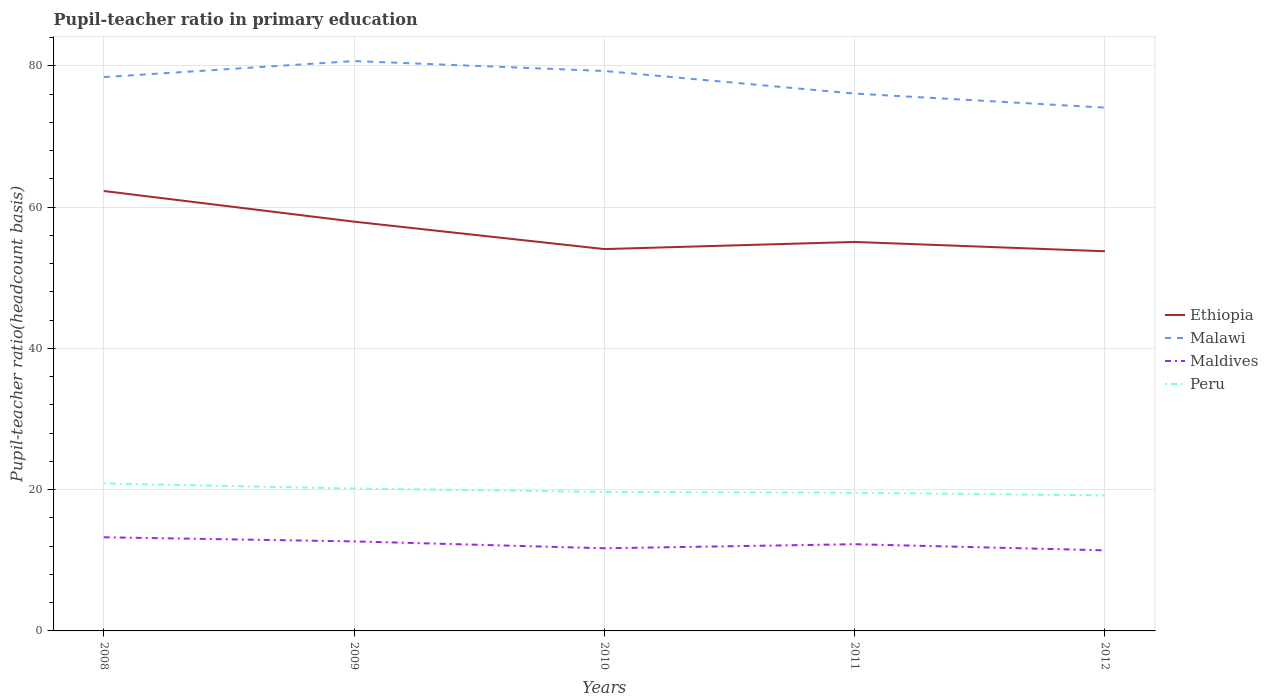Does the line corresponding to Maldives intersect with the line corresponding to Peru?
Offer a terse response. No. Is the number of lines equal to the number of legend labels?
Keep it short and to the point. Yes. Across all years, what is the maximum pupil-teacher ratio in primary education in Maldives?
Keep it short and to the point. 11.41. In which year was the pupil-teacher ratio in primary education in Malawi maximum?
Your answer should be compact. 2012. What is the total pupil-teacher ratio in primary education in Malawi in the graph?
Ensure brevity in your answer.  4.32. What is the difference between the highest and the second highest pupil-teacher ratio in primary education in Maldives?
Your answer should be compact. 1.85. What is the difference between the highest and the lowest pupil-teacher ratio in primary education in Ethiopia?
Provide a short and direct response. 2. How many lines are there?
Your answer should be very brief. 4. How many years are there in the graph?
Your answer should be very brief. 5. What is the difference between two consecutive major ticks on the Y-axis?
Give a very brief answer. 20. Are the values on the major ticks of Y-axis written in scientific E-notation?
Your response must be concise. No. Does the graph contain any zero values?
Provide a succinct answer. No. Does the graph contain grids?
Make the answer very short. Yes. Where does the legend appear in the graph?
Offer a terse response. Center right. How are the legend labels stacked?
Your answer should be very brief. Vertical. What is the title of the graph?
Your response must be concise. Pupil-teacher ratio in primary education. What is the label or title of the X-axis?
Give a very brief answer. Years. What is the label or title of the Y-axis?
Ensure brevity in your answer.  Pupil-teacher ratio(headcount basis). What is the Pupil-teacher ratio(headcount basis) in Ethiopia in 2008?
Your answer should be compact. 62.28. What is the Pupil-teacher ratio(headcount basis) in Malawi in 2008?
Your answer should be compact. 78.41. What is the Pupil-teacher ratio(headcount basis) of Maldives in 2008?
Give a very brief answer. 13.26. What is the Pupil-teacher ratio(headcount basis) in Peru in 2008?
Keep it short and to the point. 20.88. What is the Pupil-teacher ratio(headcount basis) of Ethiopia in 2009?
Your response must be concise. 57.94. What is the Pupil-teacher ratio(headcount basis) of Malawi in 2009?
Provide a succinct answer. 80.68. What is the Pupil-teacher ratio(headcount basis) in Maldives in 2009?
Offer a terse response. 12.68. What is the Pupil-teacher ratio(headcount basis) of Peru in 2009?
Give a very brief answer. 20.16. What is the Pupil-teacher ratio(headcount basis) in Ethiopia in 2010?
Give a very brief answer. 54.06. What is the Pupil-teacher ratio(headcount basis) of Malawi in 2010?
Provide a short and direct response. 79.27. What is the Pupil-teacher ratio(headcount basis) in Maldives in 2010?
Provide a short and direct response. 11.7. What is the Pupil-teacher ratio(headcount basis) of Peru in 2010?
Keep it short and to the point. 19.68. What is the Pupil-teacher ratio(headcount basis) in Ethiopia in 2011?
Give a very brief answer. 55.07. What is the Pupil-teacher ratio(headcount basis) of Malawi in 2011?
Ensure brevity in your answer.  76.07. What is the Pupil-teacher ratio(headcount basis) in Maldives in 2011?
Ensure brevity in your answer.  12.28. What is the Pupil-teacher ratio(headcount basis) in Peru in 2011?
Give a very brief answer. 19.56. What is the Pupil-teacher ratio(headcount basis) of Ethiopia in 2012?
Your response must be concise. 53.75. What is the Pupil-teacher ratio(headcount basis) of Malawi in 2012?
Keep it short and to the point. 74.09. What is the Pupil-teacher ratio(headcount basis) in Maldives in 2012?
Keep it short and to the point. 11.41. What is the Pupil-teacher ratio(headcount basis) in Peru in 2012?
Keep it short and to the point. 19.19. Across all years, what is the maximum Pupil-teacher ratio(headcount basis) of Ethiopia?
Your answer should be very brief. 62.28. Across all years, what is the maximum Pupil-teacher ratio(headcount basis) in Malawi?
Ensure brevity in your answer.  80.68. Across all years, what is the maximum Pupil-teacher ratio(headcount basis) of Maldives?
Offer a very short reply. 13.26. Across all years, what is the maximum Pupil-teacher ratio(headcount basis) in Peru?
Your answer should be very brief. 20.88. Across all years, what is the minimum Pupil-teacher ratio(headcount basis) of Ethiopia?
Keep it short and to the point. 53.75. Across all years, what is the minimum Pupil-teacher ratio(headcount basis) in Malawi?
Offer a terse response. 74.09. Across all years, what is the minimum Pupil-teacher ratio(headcount basis) in Maldives?
Provide a succinct answer. 11.41. Across all years, what is the minimum Pupil-teacher ratio(headcount basis) of Peru?
Provide a short and direct response. 19.19. What is the total Pupil-teacher ratio(headcount basis) of Ethiopia in the graph?
Keep it short and to the point. 283.1. What is the total Pupil-teacher ratio(headcount basis) in Malawi in the graph?
Your answer should be compact. 388.52. What is the total Pupil-teacher ratio(headcount basis) of Maldives in the graph?
Your answer should be very brief. 61.32. What is the total Pupil-teacher ratio(headcount basis) of Peru in the graph?
Provide a succinct answer. 99.47. What is the difference between the Pupil-teacher ratio(headcount basis) in Ethiopia in 2008 and that in 2009?
Give a very brief answer. 4.34. What is the difference between the Pupil-teacher ratio(headcount basis) of Malawi in 2008 and that in 2009?
Provide a short and direct response. -2.27. What is the difference between the Pupil-teacher ratio(headcount basis) in Maldives in 2008 and that in 2009?
Make the answer very short. 0.58. What is the difference between the Pupil-teacher ratio(headcount basis) in Peru in 2008 and that in 2009?
Provide a succinct answer. 0.72. What is the difference between the Pupil-teacher ratio(headcount basis) of Ethiopia in 2008 and that in 2010?
Provide a succinct answer. 8.22. What is the difference between the Pupil-teacher ratio(headcount basis) in Malawi in 2008 and that in 2010?
Provide a short and direct response. -0.87. What is the difference between the Pupil-teacher ratio(headcount basis) of Maldives in 2008 and that in 2010?
Your response must be concise. 1.56. What is the difference between the Pupil-teacher ratio(headcount basis) in Peru in 2008 and that in 2010?
Give a very brief answer. 1.2. What is the difference between the Pupil-teacher ratio(headcount basis) of Ethiopia in 2008 and that in 2011?
Make the answer very short. 7.21. What is the difference between the Pupil-teacher ratio(headcount basis) in Malawi in 2008 and that in 2011?
Keep it short and to the point. 2.33. What is the difference between the Pupil-teacher ratio(headcount basis) of Maldives in 2008 and that in 2011?
Make the answer very short. 0.98. What is the difference between the Pupil-teacher ratio(headcount basis) in Peru in 2008 and that in 2011?
Provide a short and direct response. 1.31. What is the difference between the Pupil-teacher ratio(headcount basis) of Ethiopia in 2008 and that in 2012?
Provide a short and direct response. 8.53. What is the difference between the Pupil-teacher ratio(headcount basis) in Malawi in 2008 and that in 2012?
Provide a succinct answer. 4.32. What is the difference between the Pupil-teacher ratio(headcount basis) in Maldives in 2008 and that in 2012?
Keep it short and to the point. 1.85. What is the difference between the Pupil-teacher ratio(headcount basis) in Peru in 2008 and that in 2012?
Your answer should be very brief. 1.69. What is the difference between the Pupil-teacher ratio(headcount basis) of Ethiopia in 2009 and that in 2010?
Make the answer very short. 3.88. What is the difference between the Pupil-teacher ratio(headcount basis) in Malawi in 2009 and that in 2010?
Keep it short and to the point. 1.41. What is the difference between the Pupil-teacher ratio(headcount basis) of Maldives in 2009 and that in 2010?
Provide a short and direct response. 0.98. What is the difference between the Pupil-teacher ratio(headcount basis) in Peru in 2009 and that in 2010?
Your answer should be very brief. 0.48. What is the difference between the Pupil-teacher ratio(headcount basis) of Ethiopia in 2009 and that in 2011?
Provide a succinct answer. 2.87. What is the difference between the Pupil-teacher ratio(headcount basis) in Malawi in 2009 and that in 2011?
Keep it short and to the point. 4.61. What is the difference between the Pupil-teacher ratio(headcount basis) of Maldives in 2009 and that in 2011?
Keep it short and to the point. 0.4. What is the difference between the Pupil-teacher ratio(headcount basis) of Peru in 2009 and that in 2011?
Provide a succinct answer. 0.59. What is the difference between the Pupil-teacher ratio(headcount basis) in Ethiopia in 2009 and that in 2012?
Provide a succinct answer. 4.19. What is the difference between the Pupil-teacher ratio(headcount basis) of Malawi in 2009 and that in 2012?
Your response must be concise. 6.59. What is the difference between the Pupil-teacher ratio(headcount basis) in Maldives in 2009 and that in 2012?
Your answer should be compact. 1.27. What is the difference between the Pupil-teacher ratio(headcount basis) of Peru in 2009 and that in 2012?
Your answer should be compact. 0.97. What is the difference between the Pupil-teacher ratio(headcount basis) in Ethiopia in 2010 and that in 2011?
Your answer should be very brief. -1.01. What is the difference between the Pupil-teacher ratio(headcount basis) in Malawi in 2010 and that in 2011?
Ensure brevity in your answer.  3.2. What is the difference between the Pupil-teacher ratio(headcount basis) of Maldives in 2010 and that in 2011?
Your answer should be very brief. -0.57. What is the difference between the Pupil-teacher ratio(headcount basis) of Peru in 2010 and that in 2011?
Make the answer very short. 0.12. What is the difference between the Pupil-teacher ratio(headcount basis) of Ethiopia in 2010 and that in 2012?
Give a very brief answer. 0.31. What is the difference between the Pupil-teacher ratio(headcount basis) of Malawi in 2010 and that in 2012?
Make the answer very short. 5.19. What is the difference between the Pupil-teacher ratio(headcount basis) of Maldives in 2010 and that in 2012?
Your answer should be very brief. 0.29. What is the difference between the Pupil-teacher ratio(headcount basis) in Peru in 2010 and that in 2012?
Your answer should be very brief. 0.49. What is the difference between the Pupil-teacher ratio(headcount basis) in Ethiopia in 2011 and that in 2012?
Make the answer very short. 1.32. What is the difference between the Pupil-teacher ratio(headcount basis) in Malawi in 2011 and that in 2012?
Give a very brief answer. 1.99. What is the difference between the Pupil-teacher ratio(headcount basis) of Maldives in 2011 and that in 2012?
Your answer should be compact. 0.87. What is the difference between the Pupil-teacher ratio(headcount basis) in Peru in 2011 and that in 2012?
Your answer should be compact. 0.38. What is the difference between the Pupil-teacher ratio(headcount basis) in Ethiopia in 2008 and the Pupil-teacher ratio(headcount basis) in Malawi in 2009?
Ensure brevity in your answer.  -18.4. What is the difference between the Pupil-teacher ratio(headcount basis) in Ethiopia in 2008 and the Pupil-teacher ratio(headcount basis) in Maldives in 2009?
Your answer should be compact. 49.61. What is the difference between the Pupil-teacher ratio(headcount basis) of Ethiopia in 2008 and the Pupil-teacher ratio(headcount basis) of Peru in 2009?
Your response must be concise. 42.13. What is the difference between the Pupil-teacher ratio(headcount basis) in Malawi in 2008 and the Pupil-teacher ratio(headcount basis) in Maldives in 2009?
Keep it short and to the point. 65.73. What is the difference between the Pupil-teacher ratio(headcount basis) of Malawi in 2008 and the Pupil-teacher ratio(headcount basis) of Peru in 2009?
Provide a short and direct response. 58.25. What is the difference between the Pupil-teacher ratio(headcount basis) of Maldives in 2008 and the Pupil-teacher ratio(headcount basis) of Peru in 2009?
Ensure brevity in your answer.  -6.9. What is the difference between the Pupil-teacher ratio(headcount basis) in Ethiopia in 2008 and the Pupil-teacher ratio(headcount basis) in Malawi in 2010?
Offer a very short reply. -16.99. What is the difference between the Pupil-teacher ratio(headcount basis) of Ethiopia in 2008 and the Pupil-teacher ratio(headcount basis) of Maldives in 2010?
Your answer should be very brief. 50.58. What is the difference between the Pupil-teacher ratio(headcount basis) of Ethiopia in 2008 and the Pupil-teacher ratio(headcount basis) of Peru in 2010?
Your answer should be very brief. 42.6. What is the difference between the Pupil-teacher ratio(headcount basis) of Malawi in 2008 and the Pupil-teacher ratio(headcount basis) of Maldives in 2010?
Your response must be concise. 66.7. What is the difference between the Pupil-teacher ratio(headcount basis) of Malawi in 2008 and the Pupil-teacher ratio(headcount basis) of Peru in 2010?
Your answer should be very brief. 58.72. What is the difference between the Pupil-teacher ratio(headcount basis) of Maldives in 2008 and the Pupil-teacher ratio(headcount basis) of Peru in 2010?
Provide a succinct answer. -6.42. What is the difference between the Pupil-teacher ratio(headcount basis) of Ethiopia in 2008 and the Pupil-teacher ratio(headcount basis) of Malawi in 2011?
Keep it short and to the point. -13.79. What is the difference between the Pupil-teacher ratio(headcount basis) in Ethiopia in 2008 and the Pupil-teacher ratio(headcount basis) in Maldives in 2011?
Your answer should be compact. 50.01. What is the difference between the Pupil-teacher ratio(headcount basis) in Ethiopia in 2008 and the Pupil-teacher ratio(headcount basis) in Peru in 2011?
Give a very brief answer. 42.72. What is the difference between the Pupil-teacher ratio(headcount basis) in Malawi in 2008 and the Pupil-teacher ratio(headcount basis) in Maldives in 2011?
Your response must be concise. 66.13. What is the difference between the Pupil-teacher ratio(headcount basis) of Malawi in 2008 and the Pupil-teacher ratio(headcount basis) of Peru in 2011?
Offer a terse response. 58.84. What is the difference between the Pupil-teacher ratio(headcount basis) in Maldives in 2008 and the Pupil-teacher ratio(headcount basis) in Peru in 2011?
Provide a succinct answer. -6.3. What is the difference between the Pupil-teacher ratio(headcount basis) in Ethiopia in 2008 and the Pupil-teacher ratio(headcount basis) in Malawi in 2012?
Offer a terse response. -11.8. What is the difference between the Pupil-teacher ratio(headcount basis) of Ethiopia in 2008 and the Pupil-teacher ratio(headcount basis) of Maldives in 2012?
Keep it short and to the point. 50.87. What is the difference between the Pupil-teacher ratio(headcount basis) in Ethiopia in 2008 and the Pupil-teacher ratio(headcount basis) in Peru in 2012?
Offer a terse response. 43.09. What is the difference between the Pupil-teacher ratio(headcount basis) of Malawi in 2008 and the Pupil-teacher ratio(headcount basis) of Maldives in 2012?
Offer a very short reply. 67. What is the difference between the Pupil-teacher ratio(headcount basis) of Malawi in 2008 and the Pupil-teacher ratio(headcount basis) of Peru in 2012?
Give a very brief answer. 59.22. What is the difference between the Pupil-teacher ratio(headcount basis) of Maldives in 2008 and the Pupil-teacher ratio(headcount basis) of Peru in 2012?
Offer a very short reply. -5.93. What is the difference between the Pupil-teacher ratio(headcount basis) in Ethiopia in 2009 and the Pupil-teacher ratio(headcount basis) in Malawi in 2010?
Ensure brevity in your answer.  -21.33. What is the difference between the Pupil-teacher ratio(headcount basis) in Ethiopia in 2009 and the Pupil-teacher ratio(headcount basis) in Maldives in 2010?
Make the answer very short. 46.24. What is the difference between the Pupil-teacher ratio(headcount basis) in Ethiopia in 2009 and the Pupil-teacher ratio(headcount basis) in Peru in 2010?
Offer a terse response. 38.26. What is the difference between the Pupil-teacher ratio(headcount basis) of Malawi in 2009 and the Pupil-teacher ratio(headcount basis) of Maldives in 2010?
Give a very brief answer. 68.98. What is the difference between the Pupil-teacher ratio(headcount basis) in Malawi in 2009 and the Pupil-teacher ratio(headcount basis) in Peru in 2010?
Your response must be concise. 61. What is the difference between the Pupil-teacher ratio(headcount basis) in Maldives in 2009 and the Pupil-teacher ratio(headcount basis) in Peru in 2010?
Your answer should be very brief. -7. What is the difference between the Pupil-teacher ratio(headcount basis) in Ethiopia in 2009 and the Pupil-teacher ratio(headcount basis) in Malawi in 2011?
Your answer should be compact. -18.13. What is the difference between the Pupil-teacher ratio(headcount basis) in Ethiopia in 2009 and the Pupil-teacher ratio(headcount basis) in Maldives in 2011?
Your answer should be compact. 45.67. What is the difference between the Pupil-teacher ratio(headcount basis) in Ethiopia in 2009 and the Pupil-teacher ratio(headcount basis) in Peru in 2011?
Keep it short and to the point. 38.38. What is the difference between the Pupil-teacher ratio(headcount basis) in Malawi in 2009 and the Pupil-teacher ratio(headcount basis) in Maldives in 2011?
Provide a succinct answer. 68.4. What is the difference between the Pupil-teacher ratio(headcount basis) in Malawi in 2009 and the Pupil-teacher ratio(headcount basis) in Peru in 2011?
Offer a very short reply. 61.12. What is the difference between the Pupil-teacher ratio(headcount basis) in Maldives in 2009 and the Pupil-teacher ratio(headcount basis) in Peru in 2011?
Make the answer very short. -6.89. What is the difference between the Pupil-teacher ratio(headcount basis) of Ethiopia in 2009 and the Pupil-teacher ratio(headcount basis) of Malawi in 2012?
Ensure brevity in your answer.  -16.15. What is the difference between the Pupil-teacher ratio(headcount basis) in Ethiopia in 2009 and the Pupil-teacher ratio(headcount basis) in Maldives in 2012?
Provide a short and direct response. 46.53. What is the difference between the Pupil-teacher ratio(headcount basis) of Ethiopia in 2009 and the Pupil-teacher ratio(headcount basis) of Peru in 2012?
Offer a terse response. 38.75. What is the difference between the Pupil-teacher ratio(headcount basis) of Malawi in 2009 and the Pupil-teacher ratio(headcount basis) of Maldives in 2012?
Provide a succinct answer. 69.27. What is the difference between the Pupil-teacher ratio(headcount basis) in Malawi in 2009 and the Pupil-teacher ratio(headcount basis) in Peru in 2012?
Give a very brief answer. 61.49. What is the difference between the Pupil-teacher ratio(headcount basis) of Maldives in 2009 and the Pupil-teacher ratio(headcount basis) of Peru in 2012?
Your answer should be very brief. -6.51. What is the difference between the Pupil-teacher ratio(headcount basis) in Ethiopia in 2010 and the Pupil-teacher ratio(headcount basis) in Malawi in 2011?
Offer a very short reply. -22.02. What is the difference between the Pupil-teacher ratio(headcount basis) in Ethiopia in 2010 and the Pupil-teacher ratio(headcount basis) in Maldives in 2011?
Your answer should be compact. 41.78. What is the difference between the Pupil-teacher ratio(headcount basis) of Ethiopia in 2010 and the Pupil-teacher ratio(headcount basis) of Peru in 2011?
Give a very brief answer. 34.49. What is the difference between the Pupil-teacher ratio(headcount basis) in Malawi in 2010 and the Pupil-teacher ratio(headcount basis) in Maldives in 2011?
Provide a short and direct response. 67. What is the difference between the Pupil-teacher ratio(headcount basis) in Malawi in 2010 and the Pupil-teacher ratio(headcount basis) in Peru in 2011?
Provide a succinct answer. 59.71. What is the difference between the Pupil-teacher ratio(headcount basis) of Maldives in 2010 and the Pupil-teacher ratio(headcount basis) of Peru in 2011?
Provide a succinct answer. -7.86. What is the difference between the Pupil-teacher ratio(headcount basis) in Ethiopia in 2010 and the Pupil-teacher ratio(headcount basis) in Malawi in 2012?
Give a very brief answer. -20.03. What is the difference between the Pupil-teacher ratio(headcount basis) in Ethiopia in 2010 and the Pupil-teacher ratio(headcount basis) in Maldives in 2012?
Ensure brevity in your answer.  42.65. What is the difference between the Pupil-teacher ratio(headcount basis) in Ethiopia in 2010 and the Pupil-teacher ratio(headcount basis) in Peru in 2012?
Offer a very short reply. 34.87. What is the difference between the Pupil-teacher ratio(headcount basis) of Malawi in 2010 and the Pupil-teacher ratio(headcount basis) of Maldives in 2012?
Offer a terse response. 67.86. What is the difference between the Pupil-teacher ratio(headcount basis) in Malawi in 2010 and the Pupil-teacher ratio(headcount basis) in Peru in 2012?
Offer a terse response. 60.08. What is the difference between the Pupil-teacher ratio(headcount basis) in Maldives in 2010 and the Pupil-teacher ratio(headcount basis) in Peru in 2012?
Give a very brief answer. -7.49. What is the difference between the Pupil-teacher ratio(headcount basis) of Ethiopia in 2011 and the Pupil-teacher ratio(headcount basis) of Malawi in 2012?
Provide a succinct answer. -19.02. What is the difference between the Pupil-teacher ratio(headcount basis) of Ethiopia in 2011 and the Pupil-teacher ratio(headcount basis) of Maldives in 2012?
Make the answer very short. 43.66. What is the difference between the Pupil-teacher ratio(headcount basis) of Ethiopia in 2011 and the Pupil-teacher ratio(headcount basis) of Peru in 2012?
Give a very brief answer. 35.88. What is the difference between the Pupil-teacher ratio(headcount basis) of Malawi in 2011 and the Pupil-teacher ratio(headcount basis) of Maldives in 2012?
Your answer should be very brief. 64.66. What is the difference between the Pupil-teacher ratio(headcount basis) in Malawi in 2011 and the Pupil-teacher ratio(headcount basis) in Peru in 2012?
Ensure brevity in your answer.  56.89. What is the difference between the Pupil-teacher ratio(headcount basis) of Maldives in 2011 and the Pupil-teacher ratio(headcount basis) of Peru in 2012?
Provide a short and direct response. -6.91. What is the average Pupil-teacher ratio(headcount basis) of Ethiopia per year?
Ensure brevity in your answer.  56.62. What is the average Pupil-teacher ratio(headcount basis) in Malawi per year?
Ensure brevity in your answer.  77.7. What is the average Pupil-teacher ratio(headcount basis) of Maldives per year?
Offer a very short reply. 12.26. What is the average Pupil-teacher ratio(headcount basis) in Peru per year?
Provide a short and direct response. 19.89. In the year 2008, what is the difference between the Pupil-teacher ratio(headcount basis) of Ethiopia and Pupil-teacher ratio(headcount basis) of Malawi?
Ensure brevity in your answer.  -16.12. In the year 2008, what is the difference between the Pupil-teacher ratio(headcount basis) of Ethiopia and Pupil-teacher ratio(headcount basis) of Maldives?
Your answer should be very brief. 49.02. In the year 2008, what is the difference between the Pupil-teacher ratio(headcount basis) in Ethiopia and Pupil-teacher ratio(headcount basis) in Peru?
Keep it short and to the point. 41.41. In the year 2008, what is the difference between the Pupil-teacher ratio(headcount basis) of Malawi and Pupil-teacher ratio(headcount basis) of Maldives?
Provide a succinct answer. 65.15. In the year 2008, what is the difference between the Pupil-teacher ratio(headcount basis) in Malawi and Pupil-teacher ratio(headcount basis) in Peru?
Your response must be concise. 57.53. In the year 2008, what is the difference between the Pupil-teacher ratio(headcount basis) in Maldives and Pupil-teacher ratio(headcount basis) in Peru?
Provide a succinct answer. -7.62. In the year 2009, what is the difference between the Pupil-teacher ratio(headcount basis) in Ethiopia and Pupil-teacher ratio(headcount basis) in Malawi?
Give a very brief answer. -22.74. In the year 2009, what is the difference between the Pupil-teacher ratio(headcount basis) in Ethiopia and Pupil-teacher ratio(headcount basis) in Maldives?
Your answer should be compact. 45.26. In the year 2009, what is the difference between the Pupil-teacher ratio(headcount basis) in Ethiopia and Pupil-teacher ratio(headcount basis) in Peru?
Provide a short and direct response. 37.78. In the year 2009, what is the difference between the Pupil-teacher ratio(headcount basis) of Malawi and Pupil-teacher ratio(headcount basis) of Maldives?
Offer a very short reply. 68. In the year 2009, what is the difference between the Pupil-teacher ratio(headcount basis) in Malawi and Pupil-teacher ratio(headcount basis) in Peru?
Provide a succinct answer. 60.52. In the year 2009, what is the difference between the Pupil-teacher ratio(headcount basis) in Maldives and Pupil-teacher ratio(headcount basis) in Peru?
Provide a short and direct response. -7.48. In the year 2010, what is the difference between the Pupil-teacher ratio(headcount basis) of Ethiopia and Pupil-teacher ratio(headcount basis) of Malawi?
Provide a succinct answer. -25.21. In the year 2010, what is the difference between the Pupil-teacher ratio(headcount basis) in Ethiopia and Pupil-teacher ratio(headcount basis) in Maldives?
Your answer should be very brief. 42.36. In the year 2010, what is the difference between the Pupil-teacher ratio(headcount basis) in Ethiopia and Pupil-teacher ratio(headcount basis) in Peru?
Your answer should be compact. 34.38. In the year 2010, what is the difference between the Pupil-teacher ratio(headcount basis) in Malawi and Pupil-teacher ratio(headcount basis) in Maldives?
Provide a succinct answer. 67.57. In the year 2010, what is the difference between the Pupil-teacher ratio(headcount basis) of Malawi and Pupil-teacher ratio(headcount basis) of Peru?
Keep it short and to the point. 59.59. In the year 2010, what is the difference between the Pupil-teacher ratio(headcount basis) in Maldives and Pupil-teacher ratio(headcount basis) in Peru?
Your response must be concise. -7.98. In the year 2011, what is the difference between the Pupil-teacher ratio(headcount basis) of Ethiopia and Pupil-teacher ratio(headcount basis) of Malawi?
Your answer should be very brief. -21. In the year 2011, what is the difference between the Pupil-teacher ratio(headcount basis) in Ethiopia and Pupil-teacher ratio(headcount basis) in Maldives?
Your answer should be very brief. 42.79. In the year 2011, what is the difference between the Pupil-teacher ratio(headcount basis) in Ethiopia and Pupil-teacher ratio(headcount basis) in Peru?
Your answer should be compact. 35.51. In the year 2011, what is the difference between the Pupil-teacher ratio(headcount basis) of Malawi and Pupil-teacher ratio(headcount basis) of Maldives?
Ensure brevity in your answer.  63.8. In the year 2011, what is the difference between the Pupil-teacher ratio(headcount basis) of Malawi and Pupil-teacher ratio(headcount basis) of Peru?
Keep it short and to the point. 56.51. In the year 2011, what is the difference between the Pupil-teacher ratio(headcount basis) of Maldives and Pupil-teacher ratio(headcount basis) of Peru?
Provide a succinct answer. -7.29. In the year 2012, what is the difference between the Pupil-teacher ratio(headcount basis) in Ethiopia and Pupil-teacher ratio(headcount basis) in Malawi?
Your answer should be compact. -20.34. In the year 2012, what is the difference between the Pupil-teacher ratio(headcount basis) in Ethiopia and Pupil-teacher ratio(headcount basis) in Maldives?
Offer a very short reply. 42.34. In the year 2012, what is the difference between the Pupil-teacher ratio(headcount basis) in Ethiopia and Pupil-teacher ratio(headcount basis) in Peru?
Make the answer very short. 34.56. In the year 2012, what is the difference between the Pupil-teacher ratio(headcount basis) of Malawi and Pupil-teacher ratio(headcount basis) of Maldives?
Give a very brief answer. 62.68. In the year 2012, what is the difference between the Pupil-teacher ratio(headcount basis) in Malawi and Pupil-teacher ratio(headcount basis) in Peru?
Your response must be concise. 54.9. In the year 2012, what is the difference between the Pupil-teacher ratio(headcount basis) of Maldives and Pupil-teacher ratio(headcount basis) of Peru?
Make the answer very short. -7.78. What is the ratio of the Pupil-teacher ratio(headcount basis) in Ethiopia in 2008 to that in 2009?
Your answer should be compact. 1.07. What is the ratio of the Pupil-teacher ratio(headcount basis) in Malawi in 2008 to that in 2009?
Your answer should be compact. 0.97. What is the ratio of the Pupil-teacher ratio(headcount basis) in Maldives in 2008 to that in 2009?
Keep it short and to the point. 1.05. What is the ratio of the Pupil-teacher ratio(headcount basis) of Peru in 2008 to that in 2009?
Your answer should be compact. 1.04. What is the ratio of the Pupil-teacher ratio(headcount basis) in Ethiopia in 2008 to that in 2010?
Your response must be concise. 1.15. What is the ratio of the Pupil-teacher ratio(headcount basis) in Maldives in 2008 to that in 2010?
Make the answer very short. 1.13. What is the ratio of the Pupil-teacher ratio(headcount basis) of Peru in 2008 to that in 2010?
Make the answer very short. 1.06. What is the ratio of the Pupil-teacher ratio(headcount basis) of Ethiopia in 2008 to that in 2011?
Your response must be concise. 1.13. What is the ratio of the Pupil-teacher ratio(headcount basis) of Malawi in 2008 to that in 2011?
Offer a terse response. 1.03. What is the ratio of the Pupil-teacher ratio(headcount basis) of Maldives in 2008 to that in 2011?
Provide a succinct answer. 1.08. What is the ratio of the Pupil-teacher ratio(headcount basis) of Peru in 2008 to that in 2011?
Keep it short and to the point. 1.07. What is the ratio of the Pupil-teacher ratio(headcount basis) in Ethiopia in 2008 to that in 2012?
Give a very brief answer. 1.16. What is the ratio of the Pupil-teacher ratio(headcount basis) in Malawi in 2008 to that in 2012?
Your answer should be compact. 1.06. What is the ratio of the Pupil-teacher ratio(headcount basis) of Maldives in 2008 to that in 2012?
Ensure brevity in your answer.  1.16. What is the ratio of the Pupil-teacher ratio(headcount basis) in Peru in 2008 to that in 2012?
Provide a succinct answer. 1.09. What is the ratio of the Pupil-teacher ratio(headcount basis) in Ethiopia in 2009 to that in 2010?
Your answer should be very brief. 1.07. What is the ratio of the Pupil-teacher ratio(headcount basis) in Malawi in 2009 to that in 2010?
Your answer should be very brief. 1.02. What is the ratio of the Pupil-teacher ratio(headcount basis) of Maldives in 2009 to that in 2010?
Provide a succinct answer. 1.08. What is the ratio of the Pupil-teacher ratio(headcount basis) in Peru in 2009 to that in 2010?
Offer a very short reply. 1.02. What is the ratio of the Pupil-teacher ratio(headcount basis) of Ethiopia in 2009 to that in 2011?
Ensure brevity in your answer.  1.05. What is the ratio of the Pupil-teacher ratio(headcount basis) in Malawi in 2009 to that in 2011?
Your response must be concise. 1.06. What is the ratio of the Pupil-teacher ratio(headcount basis) in Maldives in 2009 to that in 2011?
Your response must be concise. 1.03. What is the ratio of the Pupil-teacher ratio(headcount basis) of Peru in 2009 to that in 2011?
Ensure brevity in your answer.  1.03. What is the ratio of the Pupil-teacher ratio(headcount basis) of Ethiopia in 2009 to that in 2012?
Your response must be concise. 1.08. What is the ratio of the Pupil-teacher ratio(headcount basis) of Malawi in 2009 to that in 2012?
Keep it short and to the point. 1.09. What is the ratio of the Pupil-teacher ratio(headcount basis) in Peru in 2009 to that in 2012?
Provide a short and direct response. 1.05. What is the ratio of the Pupil-teacher ratio(headcount basis) of Ethiopia in 2010 to that in 2011?
Offer a very short reply. 0.98. What is the ratio of the Pupil-teacher ratio(headcount basis) of Malawi in 2010 to that in 2011?
Your answer should be very brief. 1.04. What is the ratio of the Pupil-teacher ratio(headcount basis) of Maldives in 2010 to that in 2011?
Make the answer very short. 0.95. What is the ratio of the Pupil-teacher ratio(headcount basis) in Peru in 2010 to that in 2011?
Provide a short and direct response. 1.01. What is the ratio of the Pupil-teacher ratio(headcount basis) of Ethiopia in 2010 to that in 2012?
Offer a very short reply. 1.01. What is the ratio of the Pupil-teacher ratio(headcount basis) of Malawi in 2010 to that in 2012?
Keep it short and to the point. 1.07. What is the ratio of the Pupil-teacher ratio(headcount basis) of Maldives in 2010 to that in 2012?
Offer a very short reply. 1.03. What is the ratio of the Pupil-teacher ratio(headcount basis) in Peru in 2010 to that in 2012?
Your response must be concise. 1.03. What is the ratio of the Pupil-teacher ratio(headcount basis) in Ethiopia in 2011 to that in 2012?
Ensure brevity in your answer.  1.02. What is the ratio of the Pupil-teacher ratio(headcount basis) in Malawi in 2011 to that in 2012?
Your answer should be compact. 1.03. What is the ratio of the Pupil-teacher ratio(headcount basis) in Maldives in 2011 to that in 2012?
Provide a short and direct response. 1.08. What is the ratio of the Pupil-teacher ratio(headcount basis) of Peru in 2011 to that in 2012?
Give a very brief answer. 1.02. What is the difference between the highest and the second highest Pupil-teacher ratio(headcount basis) in Ethiopia?
Keep it short and to the point. 4.34. What is the difference between the highest and the second highest Pupil-teacher ratio(headcount basis) in Malawi?
Keep it short and to the point. 1.41. What is the difference between the highest and the second highest Pupil-teacher ratio(headcount basis) of Maldives?
Keep it short and to the point. 0.58. What is the difference between the highest and the second highest Pupil-teacher ratio(headcount basis) of Peru?
Make the answer very short. 0.72. What is the difference between the highest and the lowest Pupil-teacher ratio(headcount basis) in Ethiopia?
Give a very brief answer. 8.53. What is the difference between the highest and the lowest Pupil-teacher ratio(headcount basis) in Malawi?
Make the answer very short. 6.59. What is the difference between the highest and the lowest Pupil-teacher ratio(headcount basis) in Maldives?
Offer a terse response. 1.85. What is the difference between the highest and the lowest Pupil-teacher ratio(headcount basis) in Peru?
Provide a succinct answer. 1.69. 